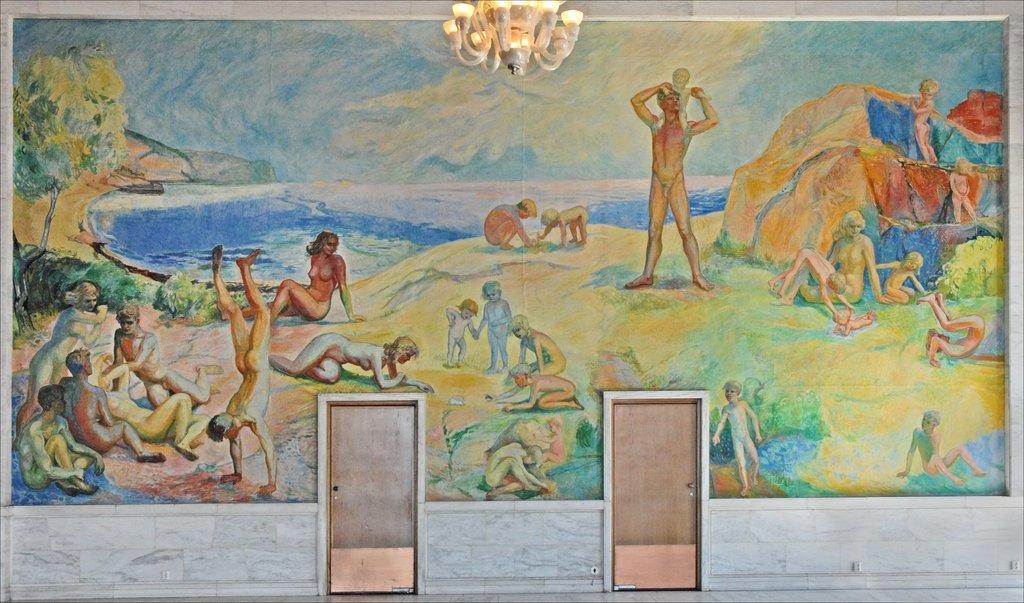Could you give a brief overview of what you see in this image? This is a painting and here we can see many people, water, trees, rocks, lights and door are there. 